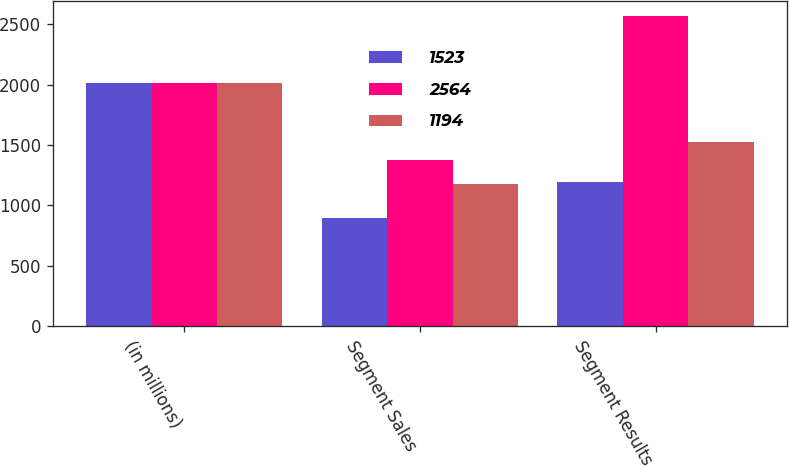<chart> <loc_0><loc_0><loc_500><loc_500><stacked_bar_chart><ecel><fcel>(in millions)<fcel>Segment Sales<fcel>Segment Results<nl><fcel>1523<fcel>2015<fcel>891<fcel>1194<nl><fcel>2564<fcel>2014<fcel>1373<fcel>2564<nl><fcel>1194<fcel>2013<fcel>1174<fcel>1523<nl></chart> 